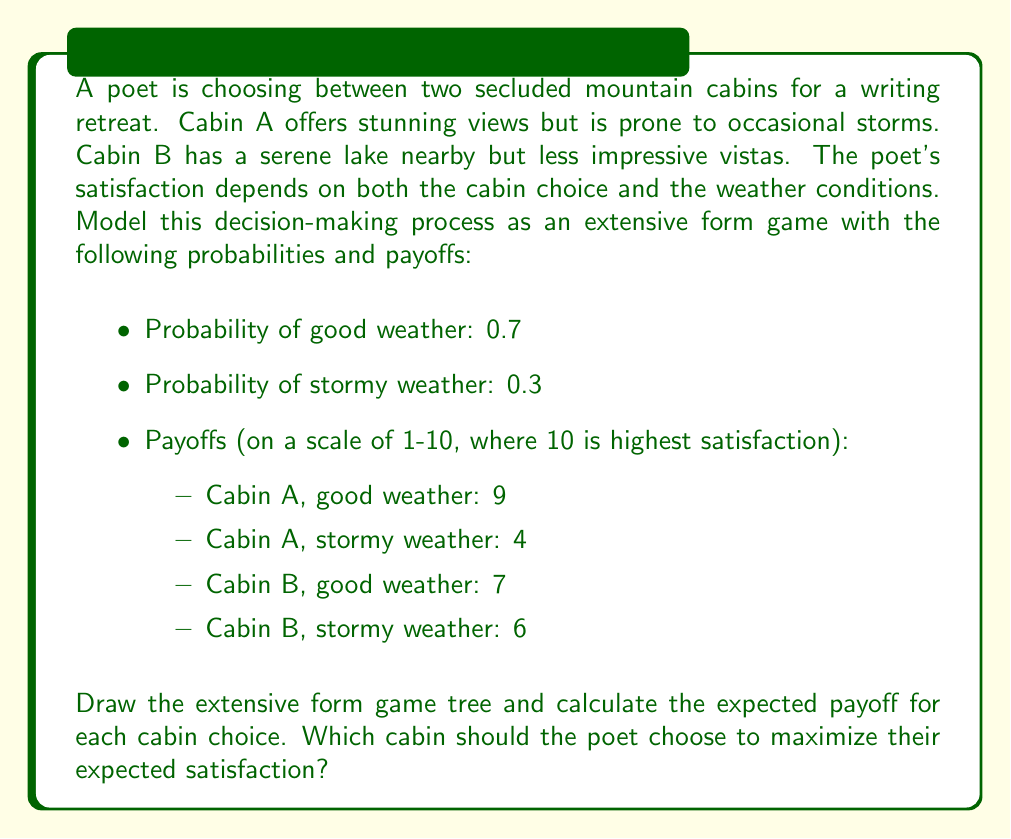Give your solution to this math problem. To solve this problem, we'll follow these steps:

1. Draw the extensive form game tree.
2. Calculate the expected payoff for each cabin choice.
3. Compare the expected payoffs to determine the optimal choice.

Step 1: Drawing the extensive form game tree

We can represent this decision-making process as an extensive form game tree:

[asy]
import geometry;

real nodesize = 3;
pen nodepen = black;
pen leafpen = gray(0.7);

void drawnode(pair p, string s = "") {
  fill(p, nodepen, circle(p, nodesize));
  label(s, p, S);
}

void drawleaf(pair p, string s = "") {
  fill(p, leafpen, circle(p, nodesize));
  label(s, p, S);
}

pair root = (0,0);
pair a = (-20,-20);
pair b = (20,-20);
pair a1 = (-30,-40);
pair a2 = (-10,-40);
pair b1 = (10,-40);
pair b2 = (30,-40);

draw(root--a);
draw(root--b);
draw(a--a1);
draw(a--a2);
draw(b--b1);
draw(b--b2);

drawnode(root, "Poet");
drawnode(a, "Nature");
drawnode(b, "Nature");
drawleaf(a1, "9");
drawleaf(a2, "4");
drawleaf(b1, "7");
drawleaf(b2, "6");

label("Cabin A", (root--a), N);
label("Cabin B", (root--b), N);
label("0.7", (a--a1), NW);
label("0.3", (a--a2), NE);
label("0.7", (b--b1), NW);
label("0.3", (b--b2), NE);
[/asy]

Step 2: Calculating the expected payoff for each cabin choice

For Cabin A:
$$ E(A) = 0.7 \cdot 9 + 0.3 \cdot 4 = 6.3 + 1.2 = 7.5 $$

For Cabin B:
$$ E(B) = 0.7 \cdot 7 + 0.3 \cdot 6 = 4.9 + 1.8 = 6.7 $$

Step 3: Comparing the expected payoffs

The expected payoff for Cabin A (7.5) is higher than the expected payoff for Cabin B (6.7).
Answer: The poet should choose Cabin A to maximize their expected satisfaction, with an expected payoff of 7.5 compared to 6.7 for Cabin B. 